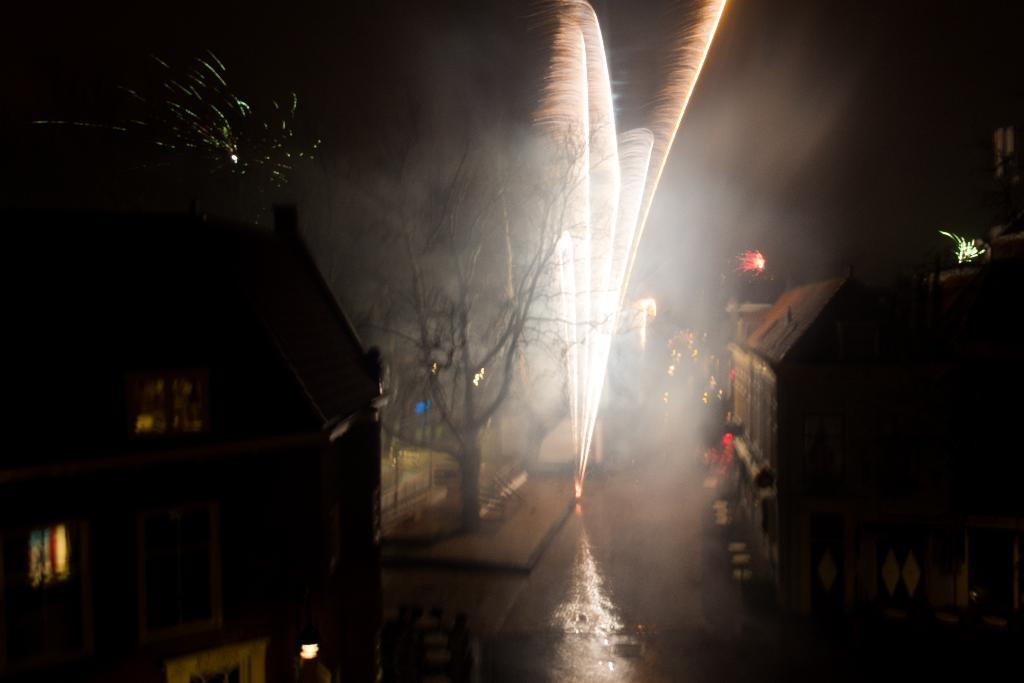Please provide a concise description of this image. Here we can see houses with windows, tree and firecrackers. 